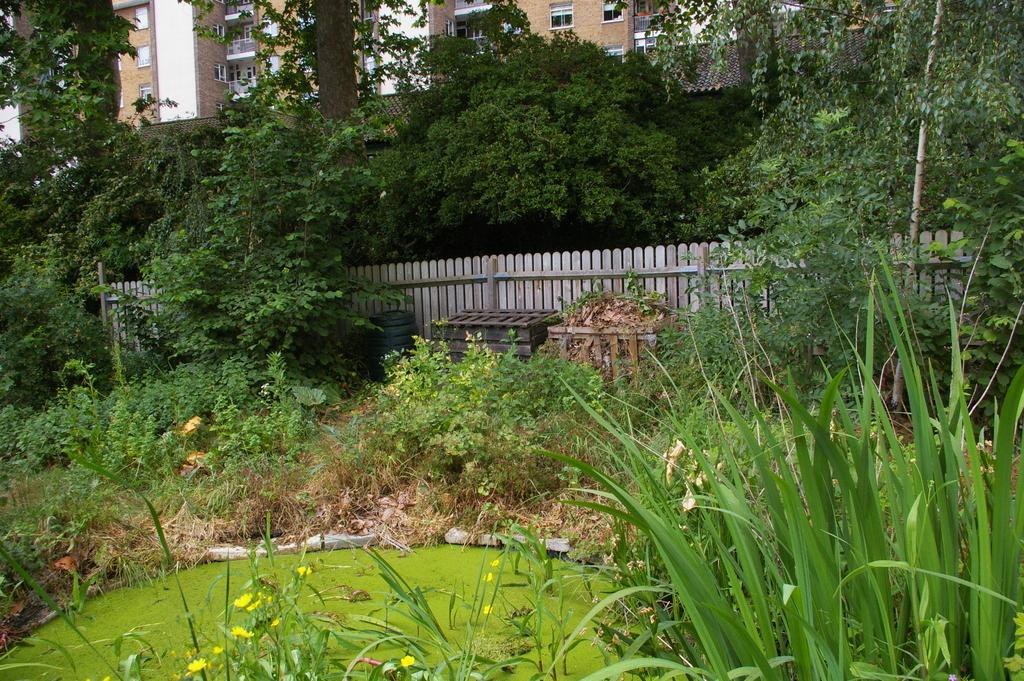What type of vegetation can be seen in the image? There is grass and plants with flowers in the image. What is used to separate or enclose the area in the image? There is a fence in the image. What type of tall plants are present in the image? There are trees in the image. What type of structures can be seen in the image? There are buildings in the image. What type of quill can be seen in the image? There is no quill present in the image. How many times does the boot twist in the image? There is no boot present in the image, so it cannot be determined how many times it might twist. 